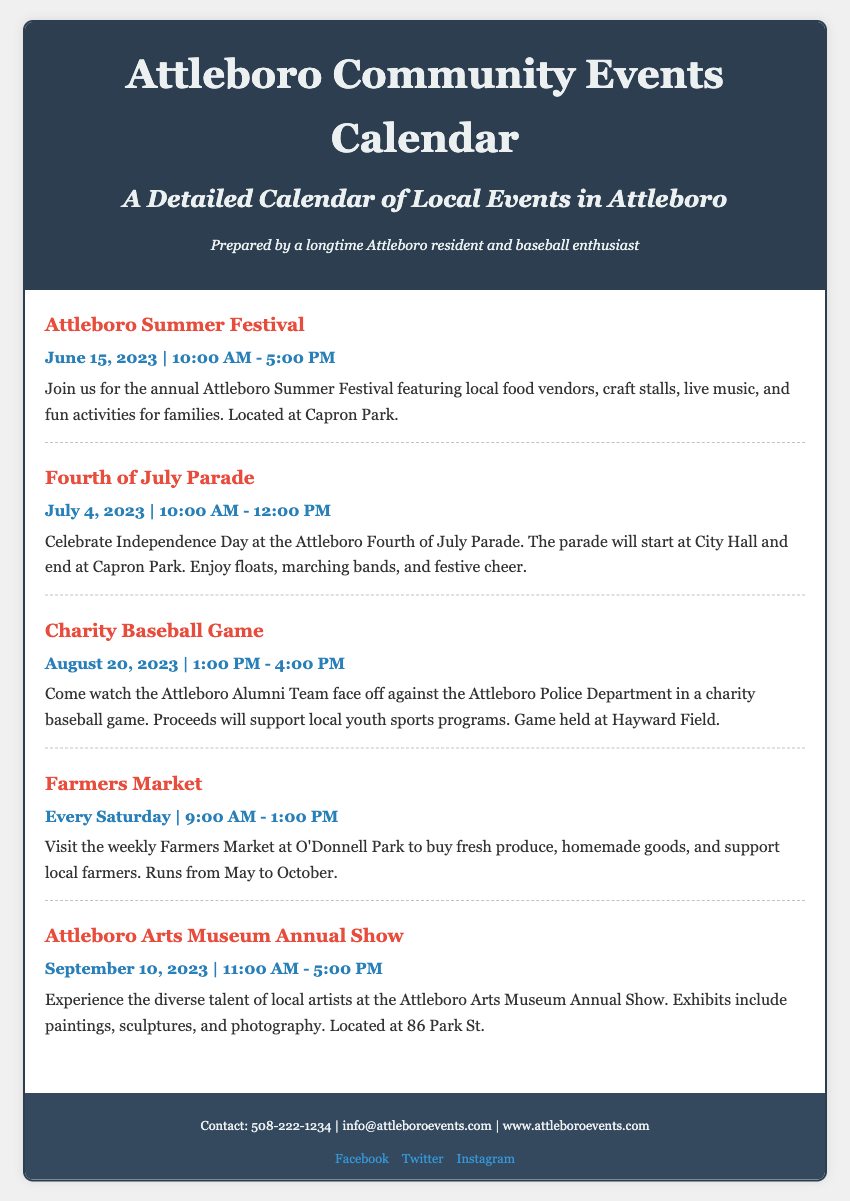What is the title of the calendar? The title is stated at the top of the document.
Answer: Attleboro Community Events Calendar What is the date of the Attleboro Summer Festival? The date is clearly indicated in the event section of the document.
Answer: June 15, 2023 Where is the Charity Baseball Game held? The location is specified in the description of the Charity Baseball Game event.
Answer: Hayward Field What time does the Farmers Market open? The time is provided in the event description for the Farmers Market.
Answer: 9:00 AM Who is playing in the Charity Baseball Game? The teams are mentioned in the event description of the Charity Baseball Game.
Answer: Attleboro Alumni Team and Attleboro Police Department What type of event occurs every Saturday? The regular event is identified in the document.
Answer: Farmers Market What is the purpose of the Charity Baseball Game? The purpose is described in the event's details.
Answer: Support local youth sports programs Which museum is hosting an annual show? The name of the museum is mentioned in the corresponding event description.
Answer: Attleboro Arts Museum What is the date of the Fourth of July Parade? The date is given in the event section of the document.
Answer: July 4, 2023 